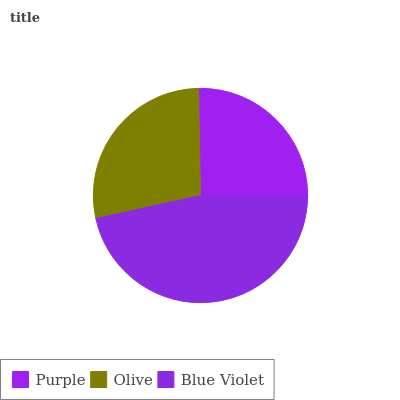Is Purple the minimum?
Answer yes or no. Yes. Is Blue Violet the maximum?
Answer yes or no. Yes. Is Olive the minimum?
Answer yes or no. No. Is Olive the maximum?
Answer yes or no. No. Is Olive greater than Purple?
Answer yes or no. Yes. Is Purple less than Olive?
Answer yes or no. Yes. Is Purple greater than Olive?
Answer yes or no. No. Is Olive less than Purple?
Answer yes or no. No. Is Olive the high median?
Answer yes or no. Yes. Is Olive the low median?
Answer yes or no. Yes. Is Blue Violet the high median?
Answer yes or no. No. Is Blue Violet the low median?
Answer yes or no. No. 